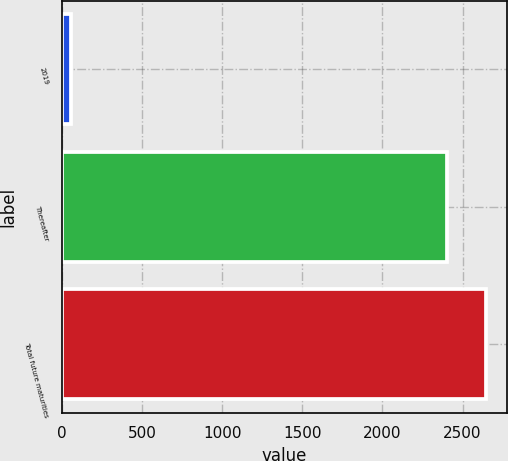Convert chart to OTSL. <chart><loc_0><loc_0><loc_500><loc_500><bar_chart><fcel>2019<fcel>Thereafter<fcel>Total future maturities<nl><fcel>54<fcel>2405<fcel>2645.5<nl></chart> 